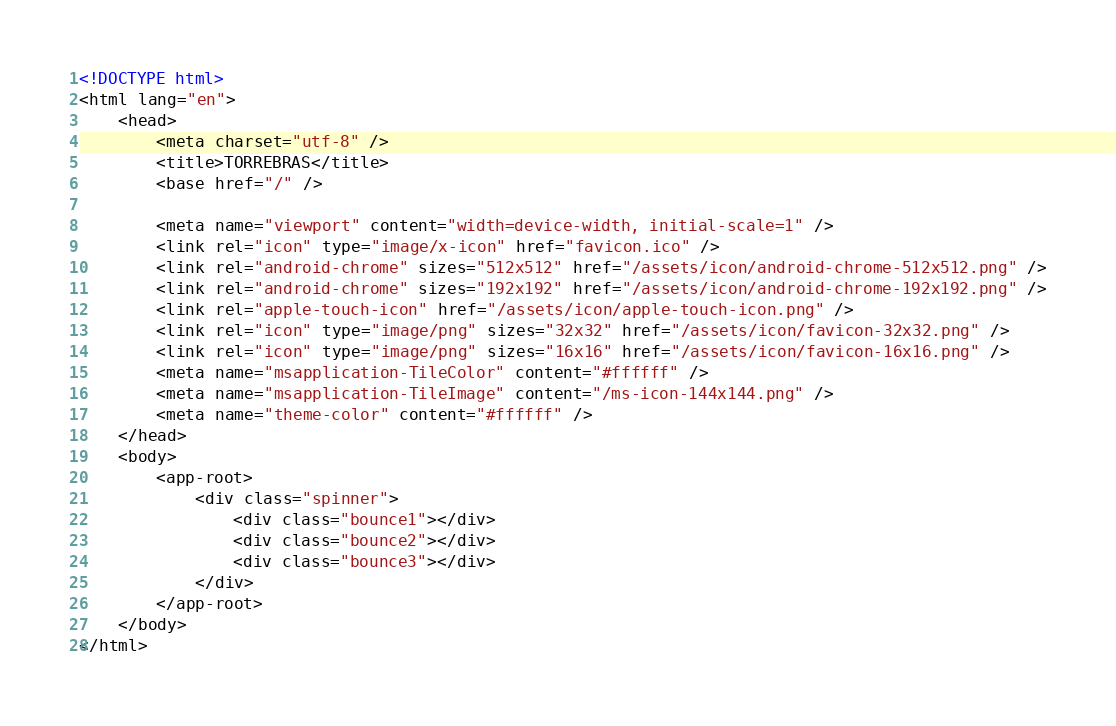<code> <loc_0><loc_0><loc_500><loc_500><_HTML_><!DOCTYPE html>
<html lang="en">
    <head>
        <meta charset="utf-8" />
        <title>TORREBRAS</title>
        <base href="/" />

        <meta name="viewport" content="width=device-width, initial-scale=1" />
        <link rel="icon" type="image/x-icon" href="favicon.ico" />
        <link rel="android-chrome" sizes="512x512" href="/assets/icon/android-chrome-512x512.png" />
        <link rel="android-chrome" sizes="192x192" href="/assets/icon/android-chrome-192x192.png" />
        <link rel="apple-touch-icon" href="/assets/icon/apple-touch-icon.png" />
        <link rel="icon" type="image/png" sizes="32x32" href="/assets/icon/favicon-32x32.png" />
        <link rel="icon" type="image/png" sizes="16x16" href="/assets/icon/favicon-16x16.png" />
        <meta name="msapplication-TileColor" content="#ffffff" />
        <meta name="msapplication-TileImage" content="/ms-icon-144x144.png" />
        <meta name="theme-color" content="#ffffff" />
    </head>
    <body>
        <app-root>
            <div class="spinner">
                <div class="bounce1"></div>
                <div class="bounce2"></div>
                <div class="bounce3"></div>
            </div>
        </app-root>
    </body>
</html>
</code> 